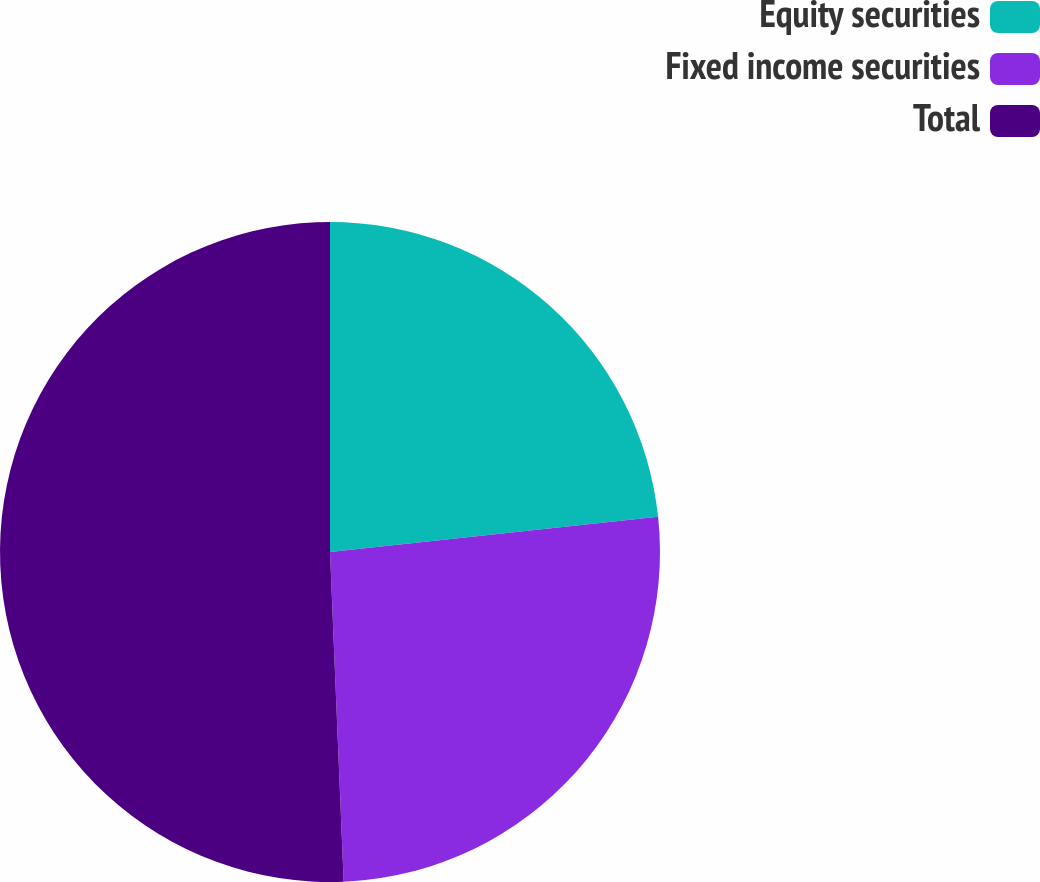Convert chart to OTSL. <chart><loc_0><loc_0><loc_500><loc_500><pie_chart><fcel>Equity securities<fcel>Fixed income securities<fcel>Total<nl><fcel>23.3%<fcel>26.04%<fcel>50.66%<nl></chart> 